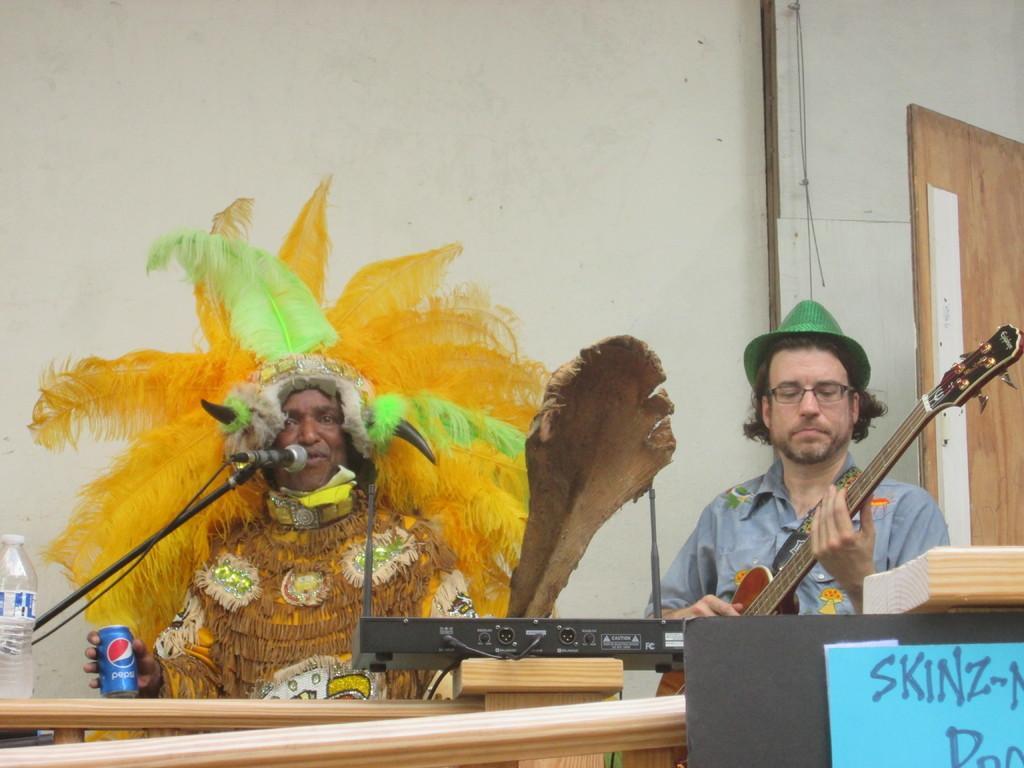Please provide a concise description of this image. In this image there are two persons who are sitting. On the right side there is one person who is sitting and he is holding a guitar and he is wearing a cap and spectacles. On the left side there is one person who is sitting and in front of him there is one mike and he is holding one coke container, in front of them there is one table and on the table there is one bottle. On the top of the image there is one wall on the right side there is door. 